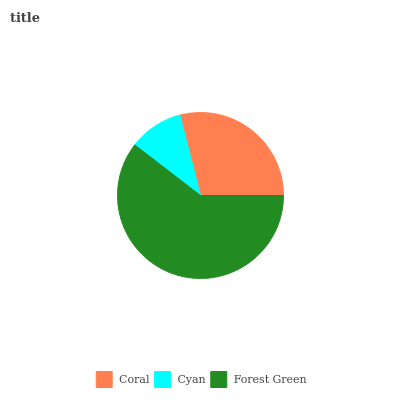Is Cyan the minimum?
Answer yes or no. Yes. Is Forest Green the maximum?
Answer yes or no. Yes. Is Forest Green the minimum?
Answer yes or no. No. Is Cyan the maximum?
Answer yes or no. No. Is Forest Green greater than Cyan?
Answer yes or no. Yes. Is Cyan less than Forest Green?
Answer yes or no. Yes. Is Cyan greater than Forest Green?
Answer yes or no. No. Is Forest Green less than Cyan?
Answer yes or no. No. Is Coral the high median?
Answer yes or no. Yes. Is Coral the low median?
Answer yes or no. Yes. Is Forest Green the high median?
Answer yes or no. No. Is Cyan the low median?
Answer yes or no. No. 